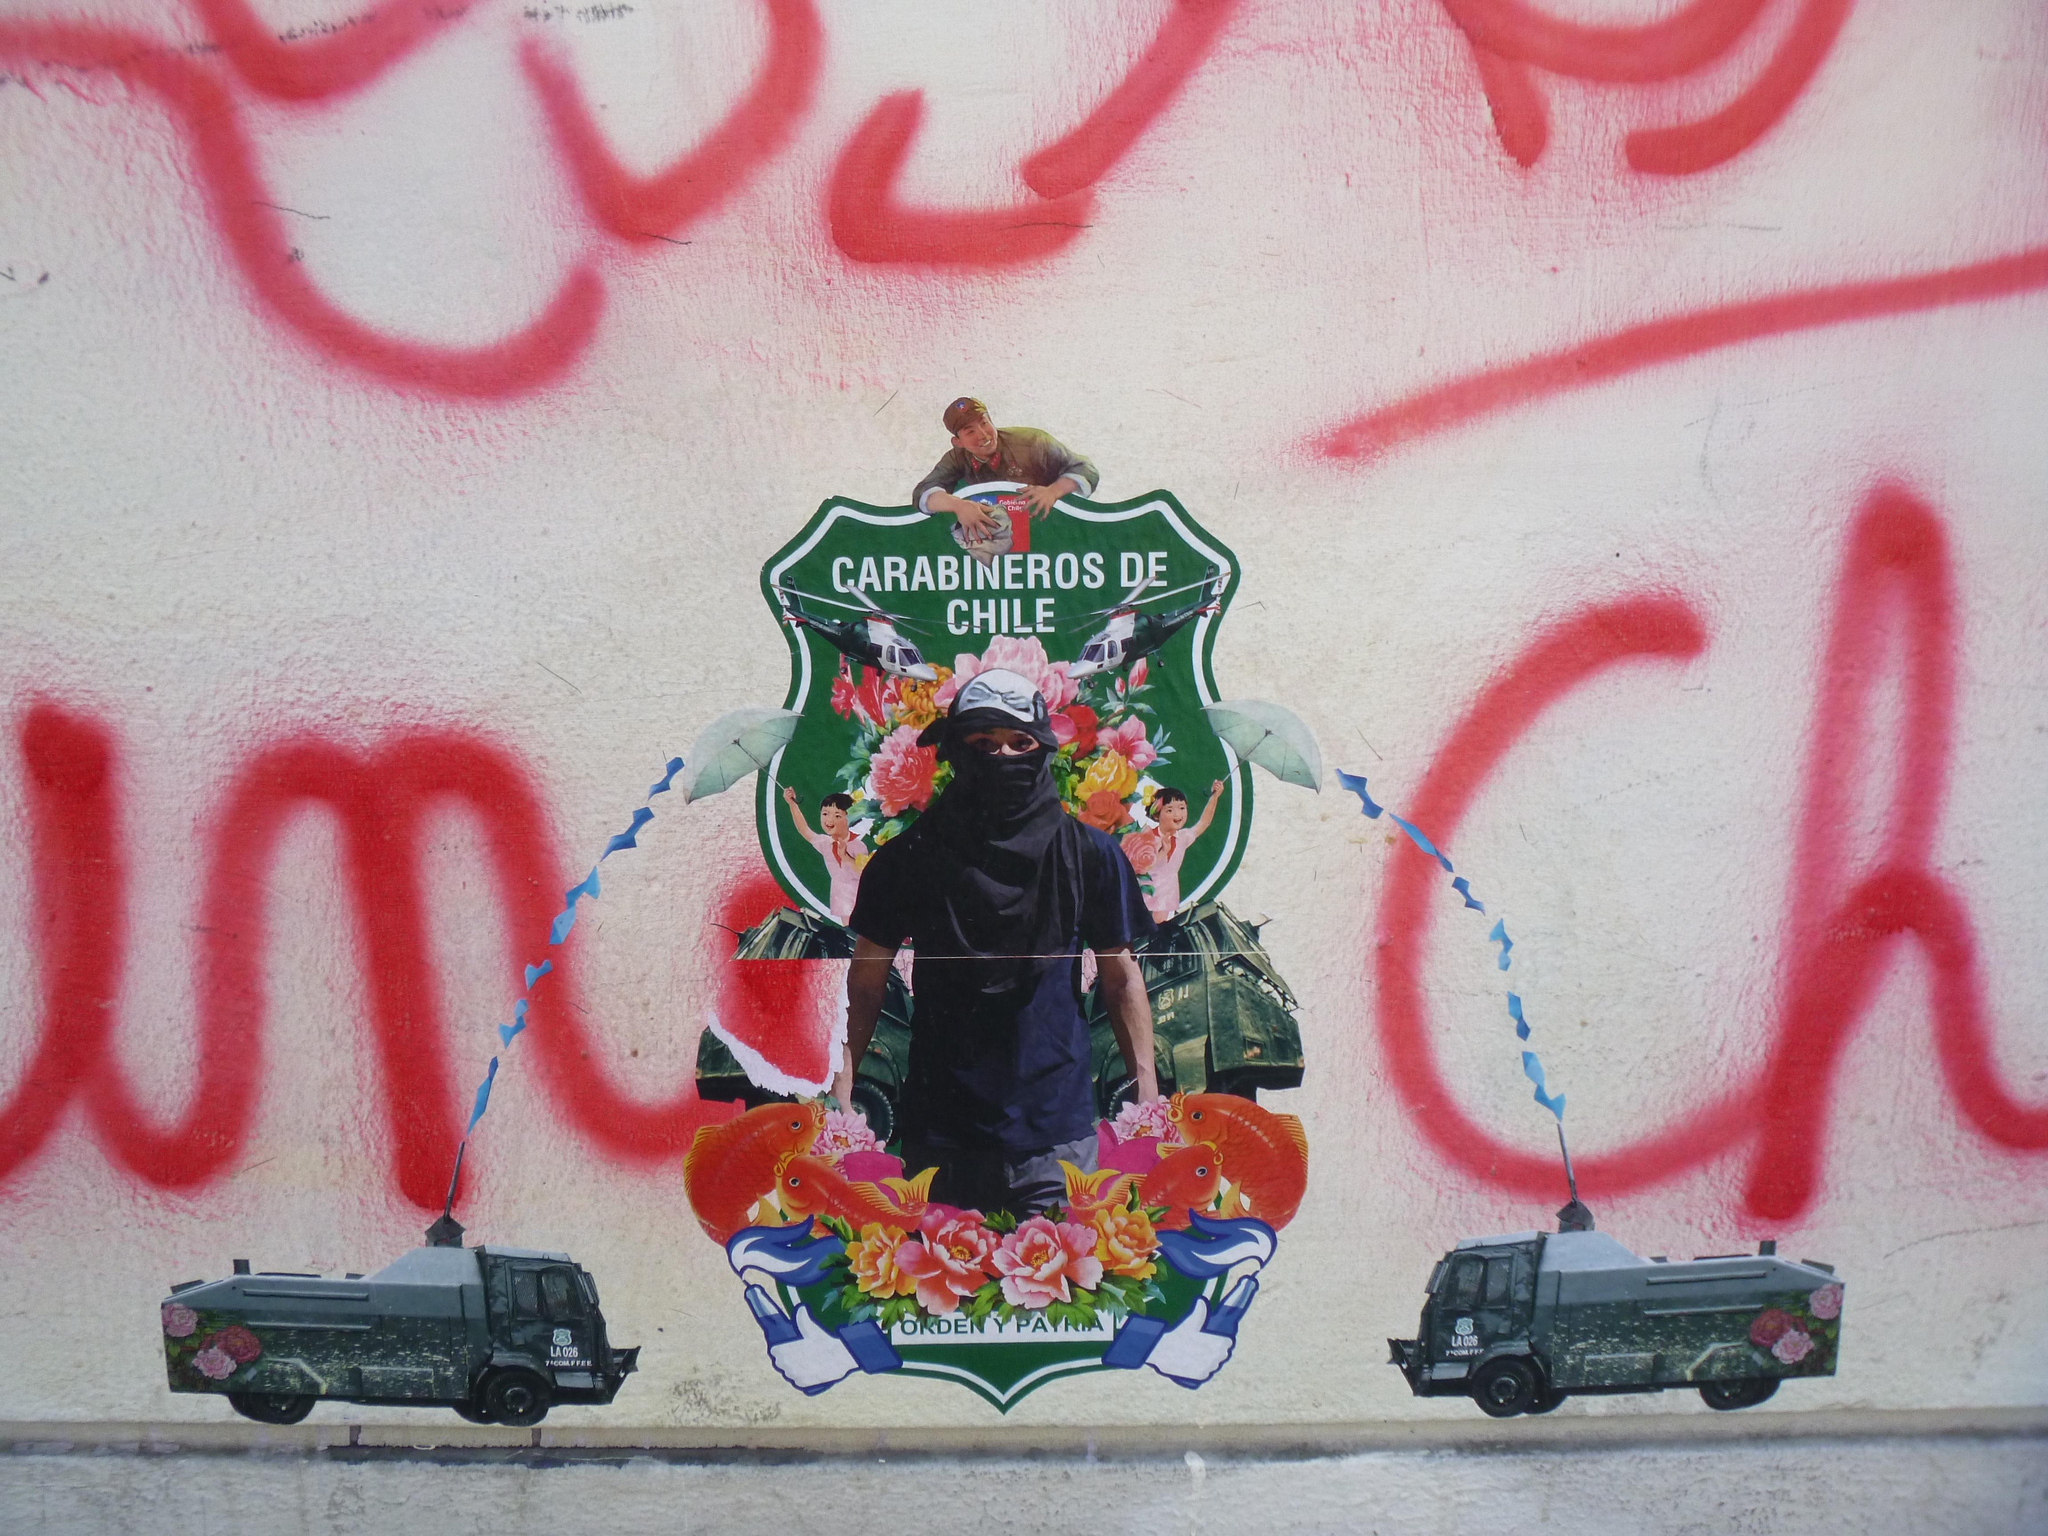What is on the wall in the image? There is a painting on the wall in the image. What types of images are included in the painting? The painting contains pictures of people, flowers, and trucks. Is there any text present in the painting? Yes, there is text on the painting. What color is the feather on the ear of the person in the painting? There is no feather on the ear of the person in the painting, as it only contains pictures of people, flowers, and trucks, along with text. 